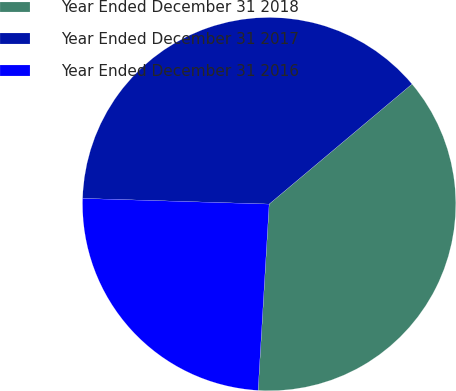Convert chart to OTSL. <chart><loc_0><loc_0><loc_500><loc_500><pie_chart><fcel>Year Ended December 31 2018<fcel>Year Ended December 31 2017<fcel>Year Ended December 31 2016<nl><fcel>37.06%<fcel>38.39%<fcel>24.54%<nl></chart> 